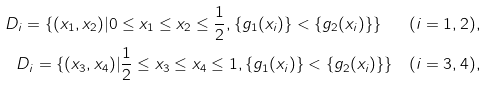Convert formula to latex. <formula><loc_0><loc_0><loc_500><loc_500>D _ { i } = \{ ( x _ { 1 } , x _ { 2 } ) | 0 \leq x _ { 1 } \leq x _ { 2 } \leq \frac { 1 } { 2 } , \{ g _ { 1 } ( x _ { i } ) \} < \{ g _ { 2 } ( x _ { i } ) \} \} \quad ( i = 1 , 2 ) , \\ D _ { i } = \{ ( x _ { 3 } , x _ { 4 } ) | \frac { 1 } { 2 } \leq x _ { 3 } \leq x _ { 4 } \leq 1 , \{ g _ { 1 } ( x _ { i } ) \} < \{ g _ { 2 } ( x _ { i } ) \} \} \quad ( i = 3 , 4 ) ,</formula> 